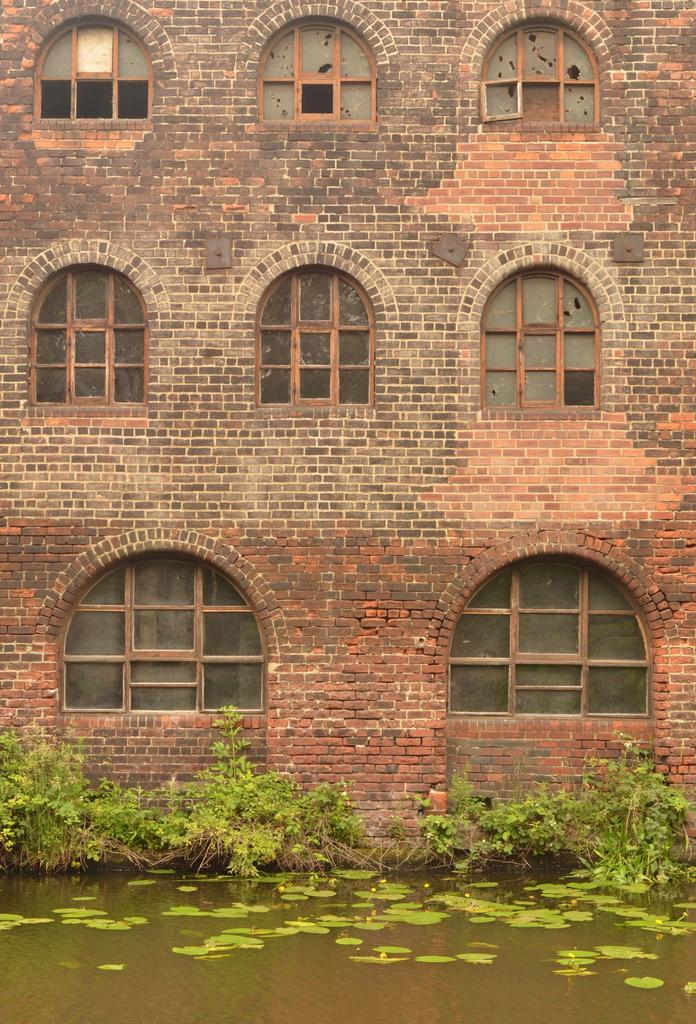Could you give a brief overview of what you see in this image? In this image I can see the water. In the background I can see few plants in green color and the building is in brown color and I can see few windows. 